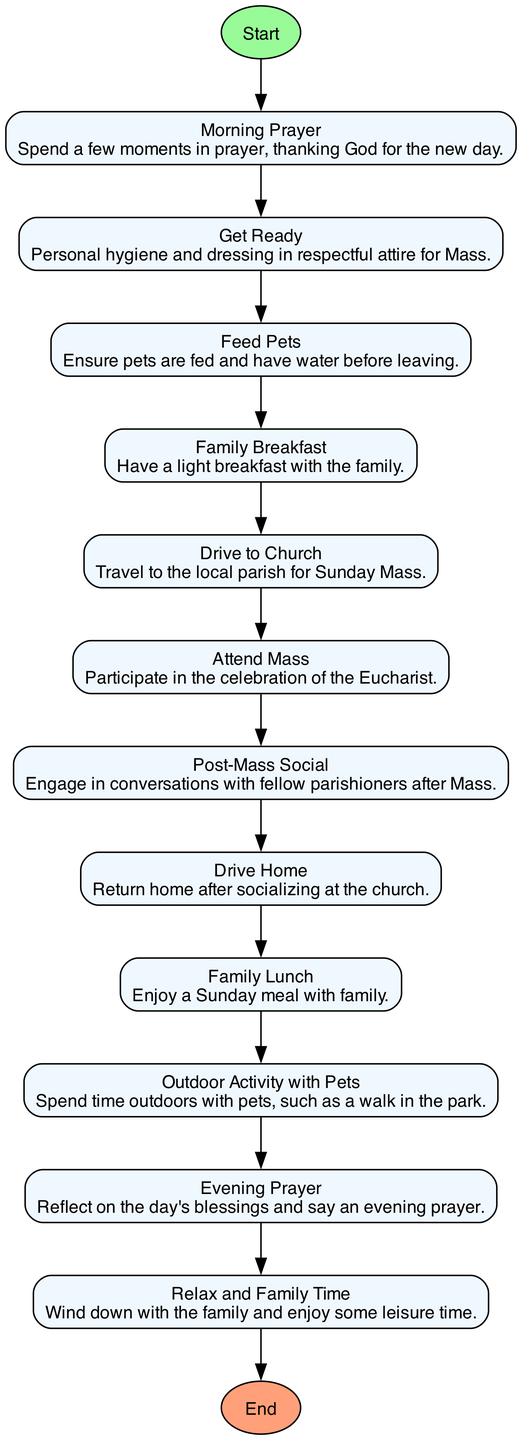What is the first step in the diagram? The first step in the diagram is labeled "Wake Up," which indicates the starting activity before any other preparations occur.
Answer: Wake Up How many steps are there in total, not including start and end? The diagram lists 10 steps that occur between the starting point "Wake Up" and the endpoint "Bedtime," as those are the activities performed on Sunday.
Answer: 10 What is the last activity before going to bed? According to the flow of the diagram, the last activity performed before going to bed is "Evening Prayer." This reflects a common practice of reflecting on the day before sleep.
Answer: Evening Prayer Which activity follows "Attend Mass"? The activity that follows "Attend Mass" in the sequence is "Post-Mass Social." This indicates a transition from the Mass celebration to social interaction with fellow congregants.
Answer: Post-Mass Social How do "Family Breakfast" and "Feed Pets" relate in the process? In the sequence, "Feed Pets" occurs before "Family Breakfast," indicating that pet care is prioritized prior to having breakfast with the family.
Answer: Feed Pets before Family Breakfast What two activities are associated with family after the Mass? After attending Mass, the activities associated with family include "Family Lunch" and "Relax and Family Time," indicating a focus on family bonding after church services.
Answer: Family Lunch and Relax and Family Time How many times is prayer mentioned in the steps? The steps mention prayer twice: once as "Morning Prayer" at the beginning and again as "Evening Prayer" at the end, emphasizing the importance of prayer throughout the day.
Answer: 2 Which step involves travel? The step that involves travel is "Drive to Church," which indicates the action of going from home to the church for the Mass service.
Answer: Drive to Church 